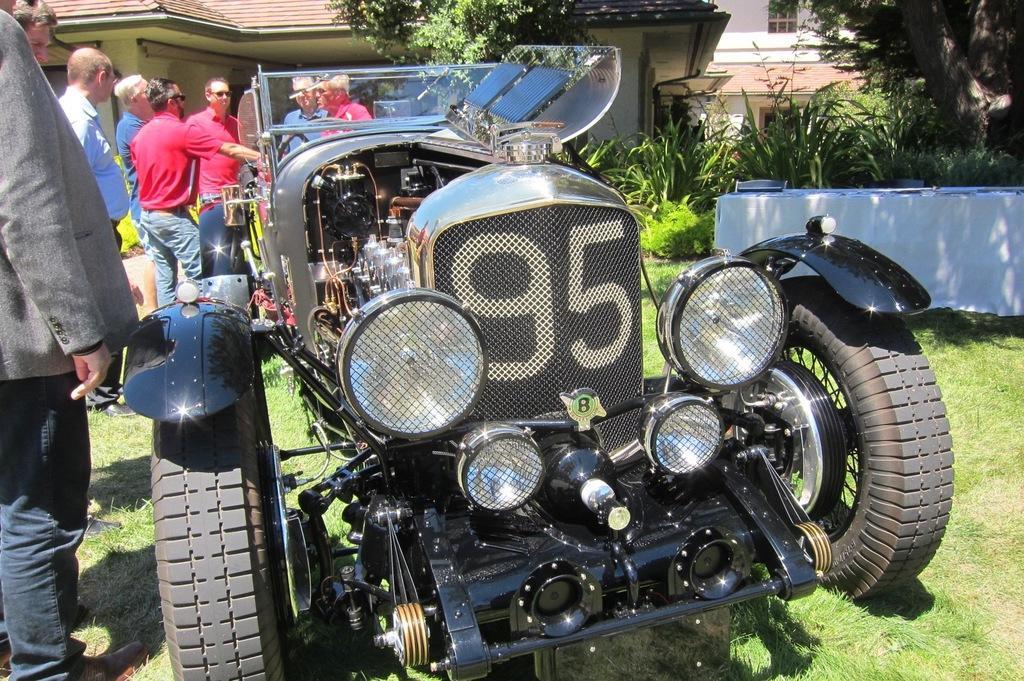Describe this image in one or two sentences. In this picture we can see old classic black color car parked in the grass lawn. Behind we can see group of men wearing red color t-shirts standing and discussing something. In the background we can see some plants and a shed house. 